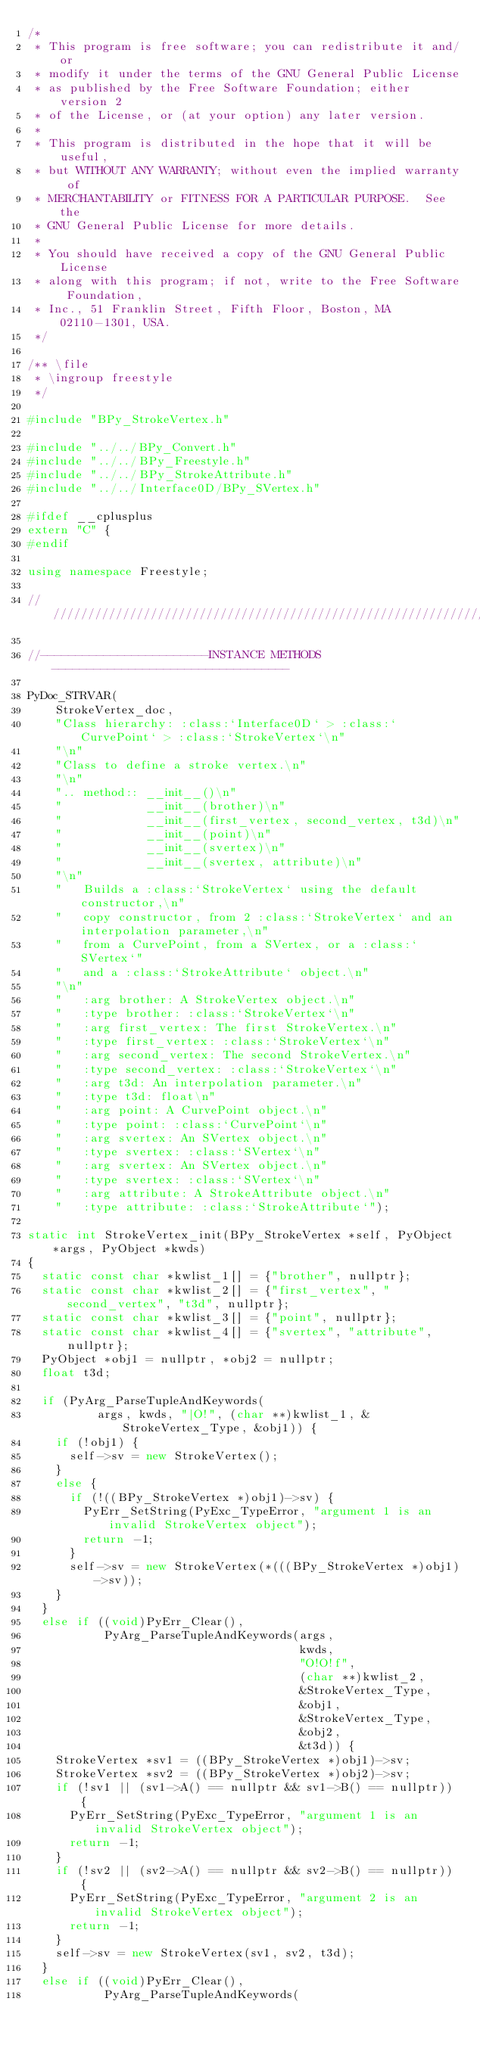Convert code to text. <code><loc_0><loc_0><loc_500><loc_500><_C++_>/*
 * This program is free software; you can redistribute it and/or
 * modify it under the terms of the GNU General Public License
 * as published by the Free Software Foundation; either version 2
 * of the License, or (at your option) any later version.
 *
 * This program is distributed in the hope that it will be useful,
 * but WITHOUT ANY WARRANTY; without even the implied warranty of
 * MERCHANTABILITY or FITNESS FOR A PARTICULAR PURPOSE.  See the
 * GNU General Public License for more details.
 *
 * You should have received a copy of the GNU General Public License
 * along with this program; if not, write to the Free Software Foundation,
 * Inc., 51 Franklin Street, Fifth Floor, Boston, MA 02110-1301, USA.
 */

/** \file
 * \ingroup freestyle
 */

#include "BPy_StrokeVertex.h"

#include "../../BPy_Convert.h"
#include "../../BPy_Freestyle.h"
#include "../../BPy_StrokeAttribute.h"
#include "../../Interface0D/BPy_SVertex.h"

#ifdef __cplusplus
extern "C" {
#endif

using namespace Freestyle;

///////////////////////////////////////////////////////////////////////////////////////////

//------------------------INSTANCE METHODS ----------------------------------

PyDoc_STRVAR(
    StrokeVertex_doc,
    "Class hierarchy: :class:`Interface0D` > :class:`CurvePoint` > :class:`StrokeVertex`\n"
    "\n"
    "Class to define a stroke vertex.\n"
    "\n"
    ".. method:: __init__()\n"
    "            __init__(brother)\n"
    "            __init__(first_vertex, second_vertex, t3d)\n"
    "            __init__(point)\n"
    "            __init__(svertex)\n"
    "            __init__(svertex, attribute)\n"
    "\n"
    "   Builds a :class:`StrokeVertex` using the default constructor,\n"
    "   copy constructor, from 2 :class:`StrokeVertex` and an interpolation parameter,\n"
    "   from a CurvePoint, from a SVertex, or a :class:`SVertex`"
    "   and a :class:`StrokeAttribute` object.\n"
    "\n"
    "   :arg brother: A StrokeVertex object.\n"
    "   :type brother: :class:`StrokeVertex`\n"
    "   :arg first_vertex: The first StrokeVertex.\n"
    "   :type first_vertex: :class:`StrokeVertex`\n"
    "   :arg second_vertex: The second StrokeVertex.\n"
    "   :type second_vertex: :class:`StrokeVertex`\n"
    "   :arg t3d: An interpolation parameter.\n"
    "   :type t3d: float\n"
    "   :arg point: A CurvePoint object.\n"
    "   :type point: :class:`CurvePoint`\n"
    "   :arg svertex: An SVertex object.\n"
    "   :type svertex: :class:`SVertex`\n"
    "   :arg svertex: An SVertex object.\n"
    "   :type svertex: :class:`SVertex`\n"
    "   :arg attribute: A StrokeAttribute object.\n"
    "   :type attribute: :class:`StrokeAttribute`");

static int StrokeVertex_init(BPy_StrokeVertex *self, PyObject *args, PyObject *kwds)
{
  static const char *kwlist_1[] = {"brother", nullptr};
  static const char *kwlist_2[] = {"first_vertex", "second_vertex", "t3d", nullptr};
  static const char *kwlist_3[] = {"point", nullptr};
  static const char *kwlist_4[] = {"svertex", "attribute", nullptr};
  PyObject *obj1 = nullptr, *obj2 = nullptr;
  float t3d;

  if (PyArg_ParseTupleAndKeywords(
          args, kwds, "|O!", (char **)kwlist_1, &StrokeVertex_Type, &obj1)) {
    if (!obj1) {
      self->sv = new StrokeVertex();
    }
    else {
      if (!((BPy_StrokeVertex *)obj1)->sv) {
        PyErr_SetString(PyExc_TypeError, "argument 1 is an invalid StrokeVertex object");
        return -1;
      }
      self->sv = new StrokeVertex(*(((BPy_StrokeVertex *)obj1)->sv));
    }
  }
  else if ((void)PyErr_Clear(),
           PyArg_ParseTupleAndKeywords(args,
                                       kwds,
                                       "O!O!f",
                                       (char **)kwlist_2,
                                       &StrokeVertex_Type,
                                       &obj1,
                                       &StrokeVertex_Type,
                                       &obj2,
                                       &t3d)) {
    StrokeVertex *sv1 = ((BPy_StrokeVertex *)obj1)->sv;
    StrokeVertex *sv2 = ((BPy_StrokeVertex *)obj2)->sv;
    if (!sv1 || (sv1->A() == nullptr && sv1->B() == nullptr)) {
      PyErr_SetString(PyExc_TypeError, "argument 1 is an invalid StrokeVertex object");
      return -1;
    }
    if (!sv2 || (sv2->A() == nullptr && sv2->B() == nullptr)) {
      PyErr_SetString(PyExc_TypeError, "argument 2 is an invalid StrokeVertex object");
      return -1;
    }
    self->sv = new StrokeVertex(sv1, sv2, t3d);
  }
  else if ((void)PyErr_Clear(),
           PyArg_ParseTupleAndKeywords(</code> 